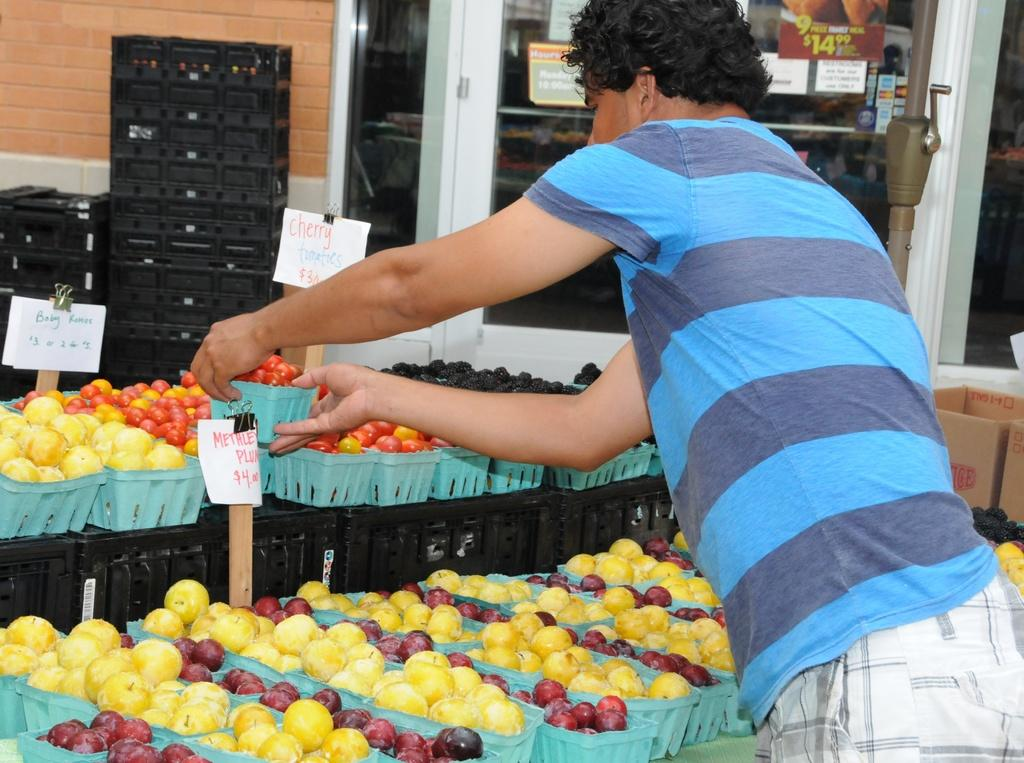What is on the right side of the image? There is a man on the right side of the image. What is the man holding in the image? The man is holding a basket in the image. What is inside the basket? There are fruits in the basket. What can be seen in the background of the image? There are posts visible in the background of the image. What is the surface of the posts resting on? The posts are on a glass surface. What type of vest is the man wearing in the image? There is no mention of a vest in the image, so it cannot be determined if the man is wearing one. 